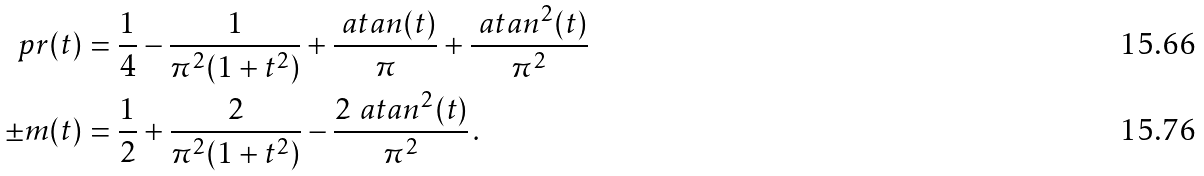Convert formula to latex. <formula><loc_0><loc_0><loc_500><loc_500>\ p r ( t ) & = \frac { 1 } { 4 } - \frac { 1 } { \pi ^ { 2 } ( 1 + t ^ { 2 } ) } + \frac { \ a t a n ( t ) } { \pi } + \frac { \ a t a n ^ { 2 } ( t ) } { \pi ^ { 2 } } \\ \pm m ( t ) & = \frac { 1 } { 2 } + \frac { 2 } { \pi ^ { 2 } ( 1 + t ^ { 2 } ) } - \frac { 2 \ a t a n ^ { 2 } ( t ) } { \pi ^ { 2 } } \, .</formula> 